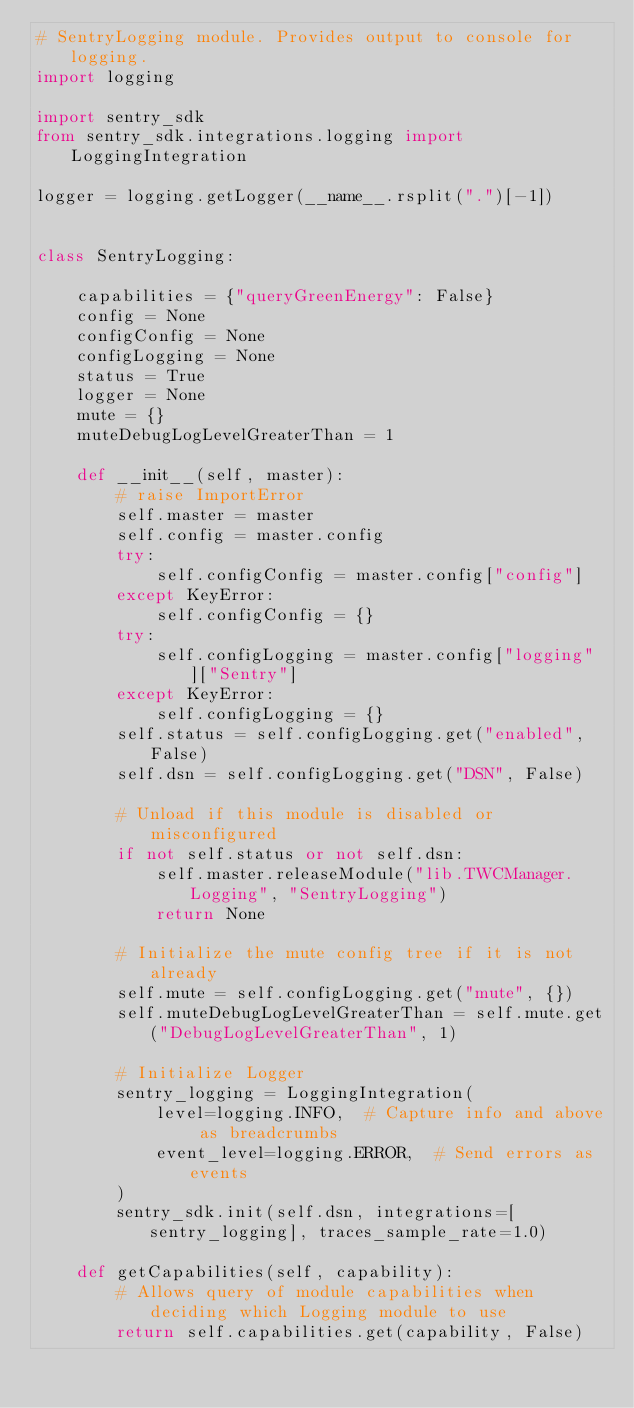Convert code to text. <code><loc_0><loc_0><loc_500><loc_500><_Python_># SentryLogging module. Provides output to console for logging.
import logging

import sentry_sdk
from sentry_sdk.integrations.logging import LoggingIntegration

logger = logging.getLogger(__name__.rsplit(".")[-1])


class SentryLogging:

    capabilities = {"queryGreenEnergy": False}
    config = None
    configConfig = None
    configLogging = None
    status = True
    logger = None
    mute = {}
    muteDebugLogLevelGreaterThan = 1

    def __init__(self, master):
        # raise ImportError
        self.master = master
        self.config = master.config
        try:
            self.configConfig = master.config["config"]
        except KeyError:
            self.configConfig = {}
        try:
            self.configLogging = master.config["logging"]["Sentry"]
        except KeyError:
            self.configLogging = {}
        self.status = self.configLogging.get("enabled", False)
        self.dsn = self.configLogging.get("DSN", False)

        # Unload if this module is disabled or misconfigured
        if not self.status or not self.dsn:
            self.master.releaseModule("lib.TWCManager.Logging", "SentryLogging")
            return None

        # Initialize the mute config tree if it is not already
        self.mute = self.configLogging.get("mute", {})
        self.muteDebugLogLevelGreaterThan = self.mute.get("DebugLogLevelGreaterThan", 1)

        # Initialize Logger
        sentry_logging = LoggingIntegration(
            level=logging.INFO,  # Capture info and above as breadcrumbs
            event_level=logging.ERROR,  # Send errors as events
        )
        sentry_sdk.init(self.dsn, integrations=[sentry_logging], traces_sample_rate=1.0)

    def getCapabilities(self, capability):
        # Allows query of module capabilities when deciding which Logging module to use
        return self.capabilities.get(capability, False)
</code> 